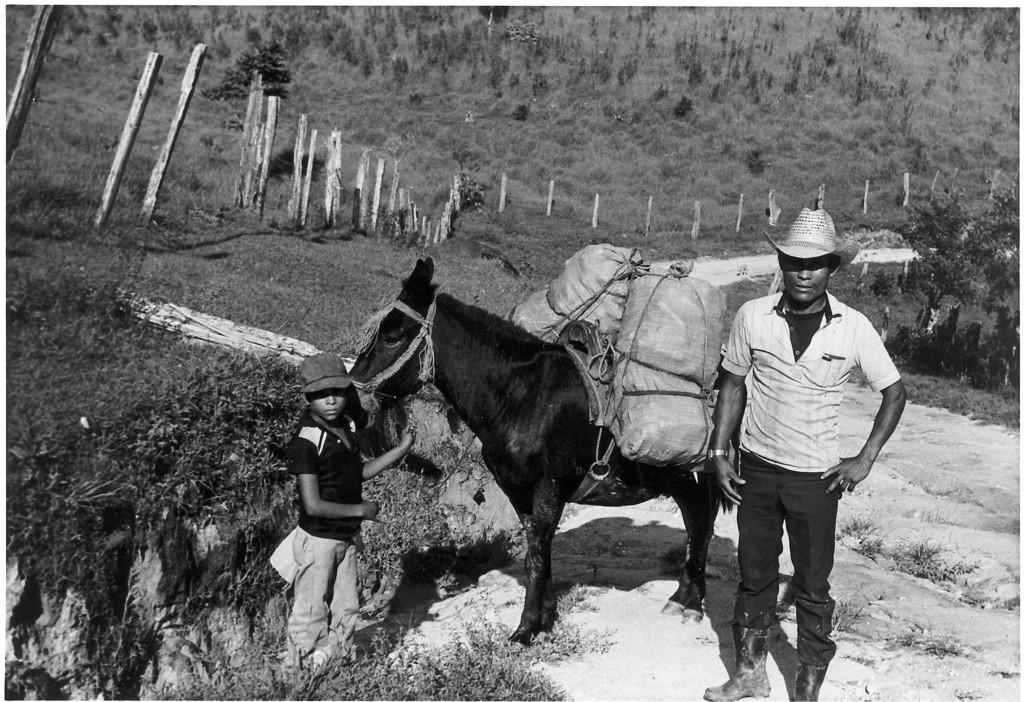What is the position of the person in the image? There is a person standing on the right side of the image. What is the position of the boy in the image? There is a boy standing on the left side of the image. What type of living creature can be seen in the image? There is an animal visible in the image. What type of vegetation is present in the image? Trees are present in the image. What type of flag is visible in the image? There is no flag present in the image. Where is the cellar located in the image? There is no mention of a cellar in the image. 